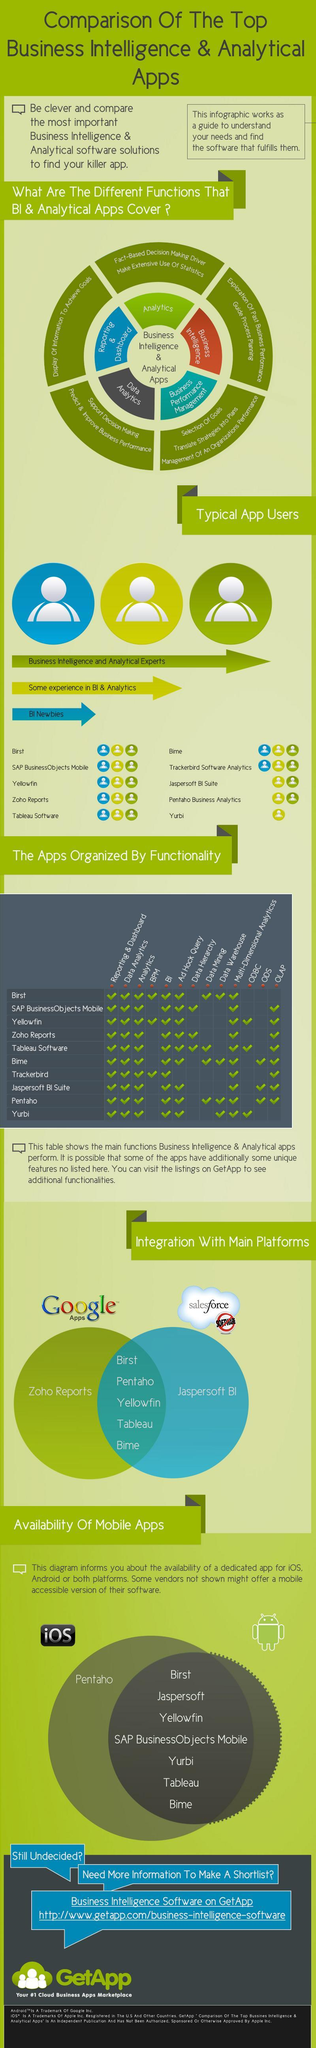how many apps do not have ODS
Answer the question with a short phrase. 7 which is the app that is only for IOS Pentaho how many apps do not have both BI and Ad Hock Query 1 Pentaho Business Analytics doesnt cover which user BI Newbies Jaspersoft BI Suite doesnt cover which user BI Newbies Yurbi caters to which user some experience in BI & Analytics 